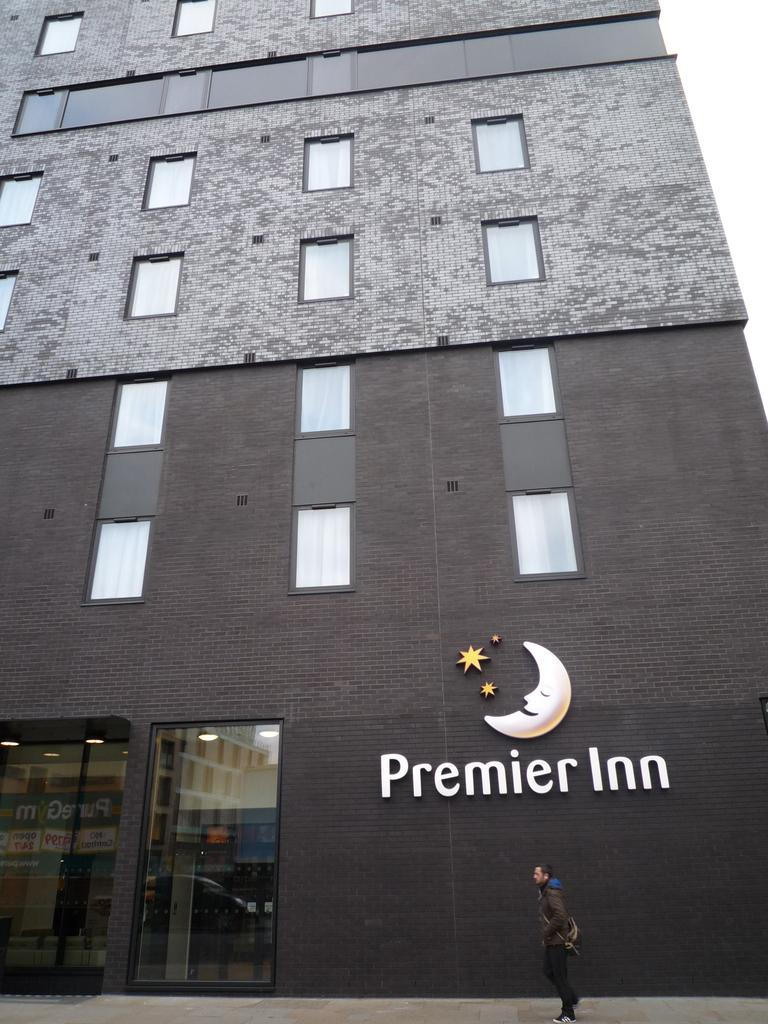<image>
Write a terse but informative summary of the picture. a building that says the premier inn on the front 